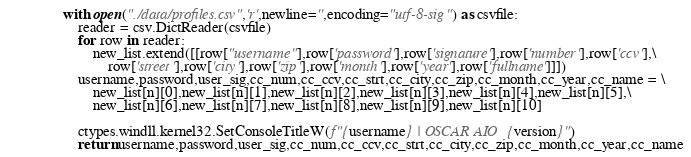Convert code to text. <code><loc_0><loc_0><loc_500><loc_500><_Python_>    with open("./data/profiles.csv",'r',newline='',encoding="utf-8-sig") as csvfile:
        reader = csv.DictReader(csvfile)
        for row in reader:
            new_list.extend([[row["username"],row['password'],row['signature'],row['number'],row['ccv'],\
                row['street'],row['city'],row['zip'],row['month'],row['year'],row['fullname']]])
        username,password,user_sig,cc_num,cc_ccv,cc_strt,cc_city,cc_zip,cc_month,cc_year,cc_name = \
            new_list[n][0],new_list[n][1],new_list[n][2],new_list[n][3],new_list[n][4],new_list[n][5],\
            new_list[n][6],new_list[n][7],new_list[n][8],new_list[n][9],new_list[n][10]

        ctypes.windll.kernel32.SetConsoleTitleW(f"{username} | OSCAR AIO {version}")
        return username,password,user_sig,cc_num,cc_ccv,cc_strt,cc_city,cc_zip,cc_month,cc_year,cc_name
</code> 